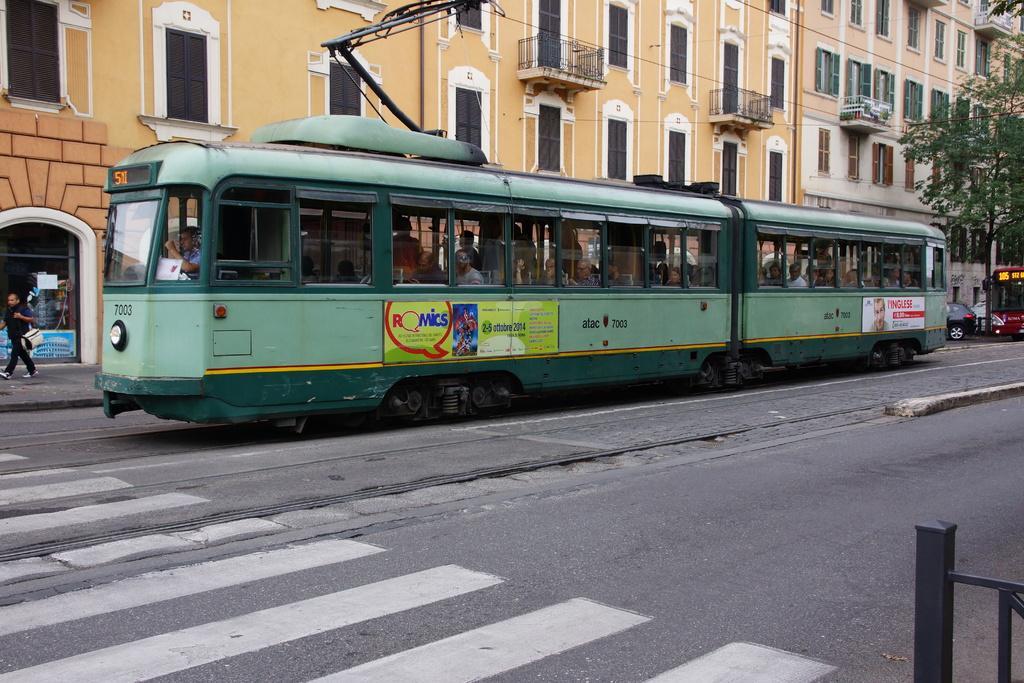Can you describe this image briefly? In this picture I can see the train on the road. Inside the train I can see many persons who are sitting on the seat and some persons are standing. On the left there is a man who is wearing black dress. He is walking on the street. At the bottom I can see the zebra crossing. On the right I can see the bus and car which are parked near to the tree. In the back I can see the buildings. At the top I can see many windows. 